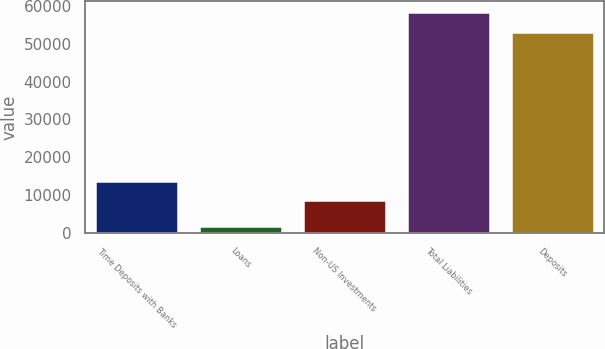Convert chart to OTSL. <chart><loc_0><loc_0><loc_500><loc_500><bar_chart><fcel>Time Deposits with Banks<fcel>Loans<fcel>Non-US Investments<fcel>Total Liabilities<fcel>Deposits<nl><fcel>13867<fcel>1759.4<fcel>8590.8<fcel>58257.4<fcel>52981.2<nl></chart> 